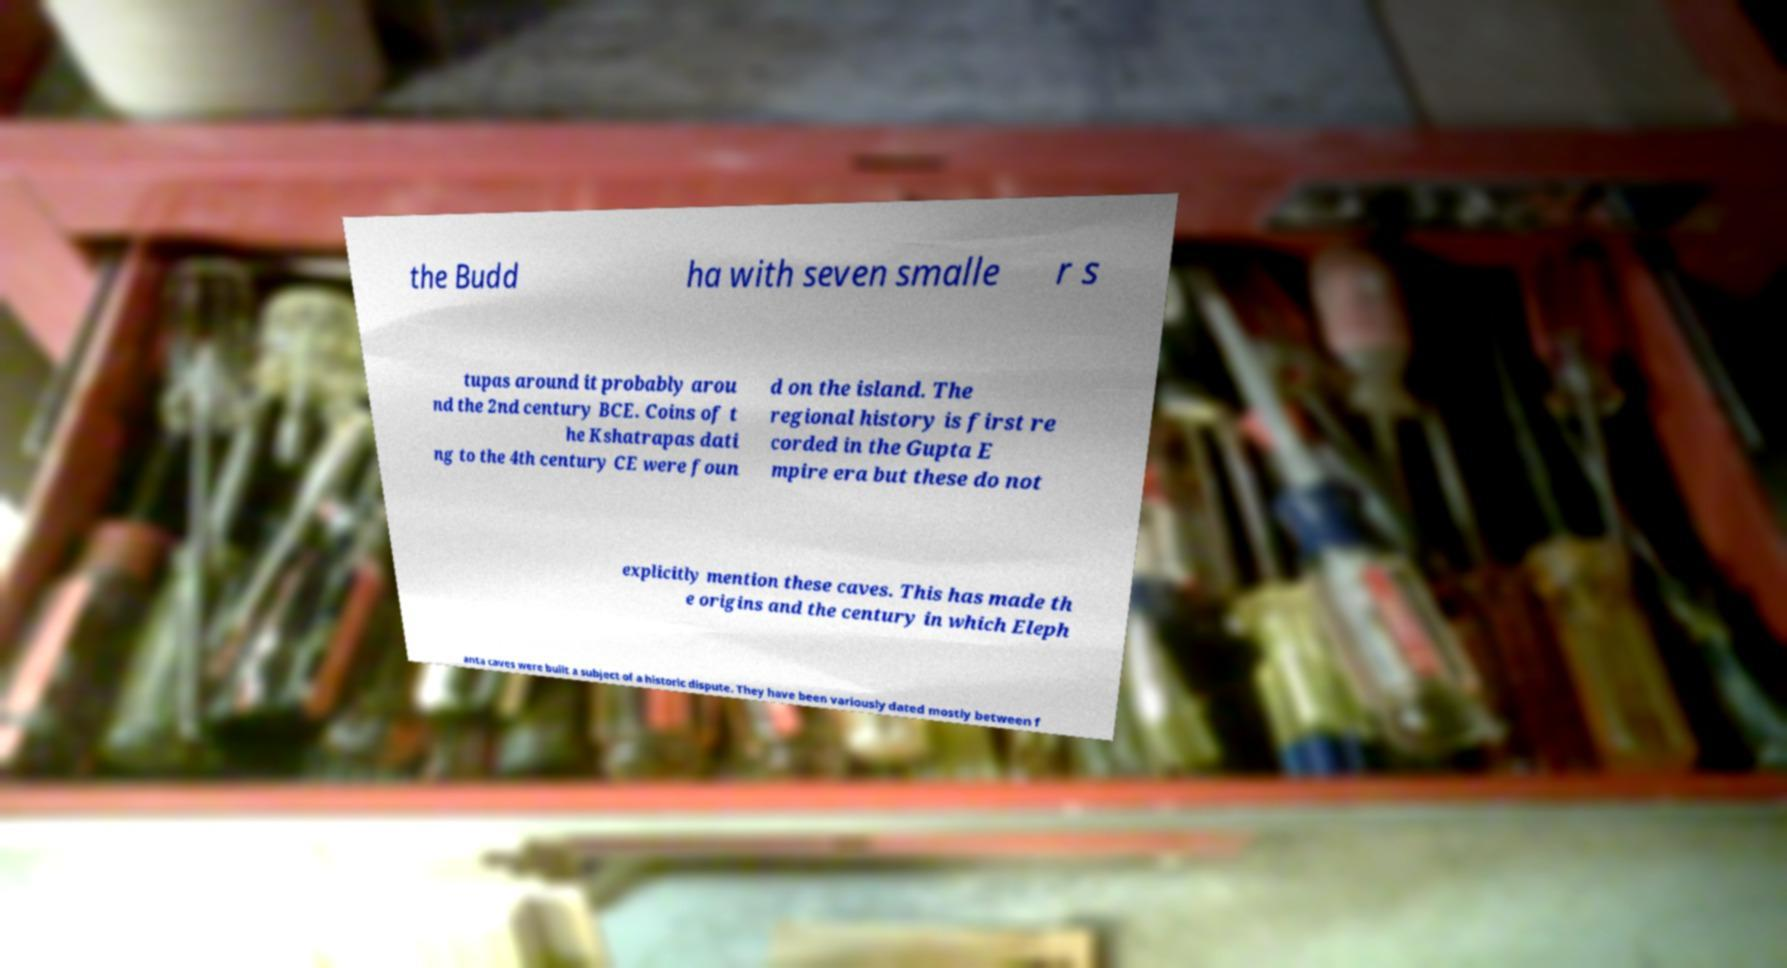Could you assist in decoding the text presented in this image and type it out clearly? the Budd ha with seven smalle r s tupas around it probably arou nd the 2nd century BCE. Coins of t he Kshatrapas dati ng to the 4th century CE were foun d on the island. The regional history is first re corded in the Gupta E mpire era but these do not explicitly mention these caves. This has made th e origins and the century in which Eleph anta caves were built a subject of a historic dispute. They have been variously dated mostly between f 